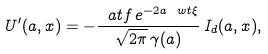<formula> <loc_0><loc_0><loc_500><loc_500>U ^ { \prime } ( a , x ) = - \frac { \ a t f \, e ^ { - 2 a \ w t \xi } } { \sqrt { 2 \pi } \, \gamma ( a ) } \, I _ { d } ( a , x ) ,</formula> 